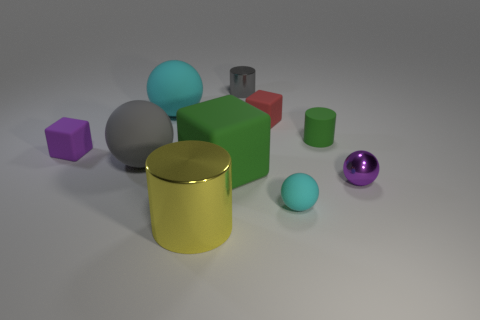What is the size of the gray metallic thing?
Your response must be concise. Small. Is the size of the green rubber object that is to the left of the red matte block the same as the gray cylinder?
Provide a short and direct response. No. How many small cylinders are in front of the small red block and behind the large cyan sphere?
Give a very brief answer. 0. How many other things have the same shape as the yellow thing?
Provide a short and direct response. 2. Do the tiny gray thing and the large cylinder have the same material?
Offer a terse response. Yes. There is a cyan matte thing on the right side of the cyan rubber object to the left of the large yellow metallic thing; what shape is it?
Keep it short and to the point. Sphere. There is a tiny block on the right side of the yellow shiny thing; how many cylinders are behind it?
Your response must be concise. 1. The small thing that is to the left of the green matte cylinder and on the right side of the red matte object is made of what material?
Your answer should be very brief. Rubber. The green rubber object that is the same size as the gray matte thing is what shape?
Your answer should be very brief. Cube. There is a tiny cube that is in front of the tiny rubber block right of the big yellow cylinder that is to the left of the green rubber block; what color is it?
Provide a succinct answer. Purple. 